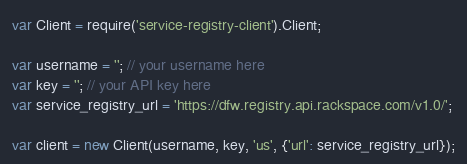<code> <loc_0><loc_0><loc_500><loc_500><_JavaScript_>var Client = require('service-registry-client').Client;

var username = ''; // your username here
var key = ''; // your API key here
var service_registry_url = 'https://dfw.registry.api.rackspace.com/v1.0/';

var client = new Client(username, key, 'us', {'url': service_registry_url});
</code> 